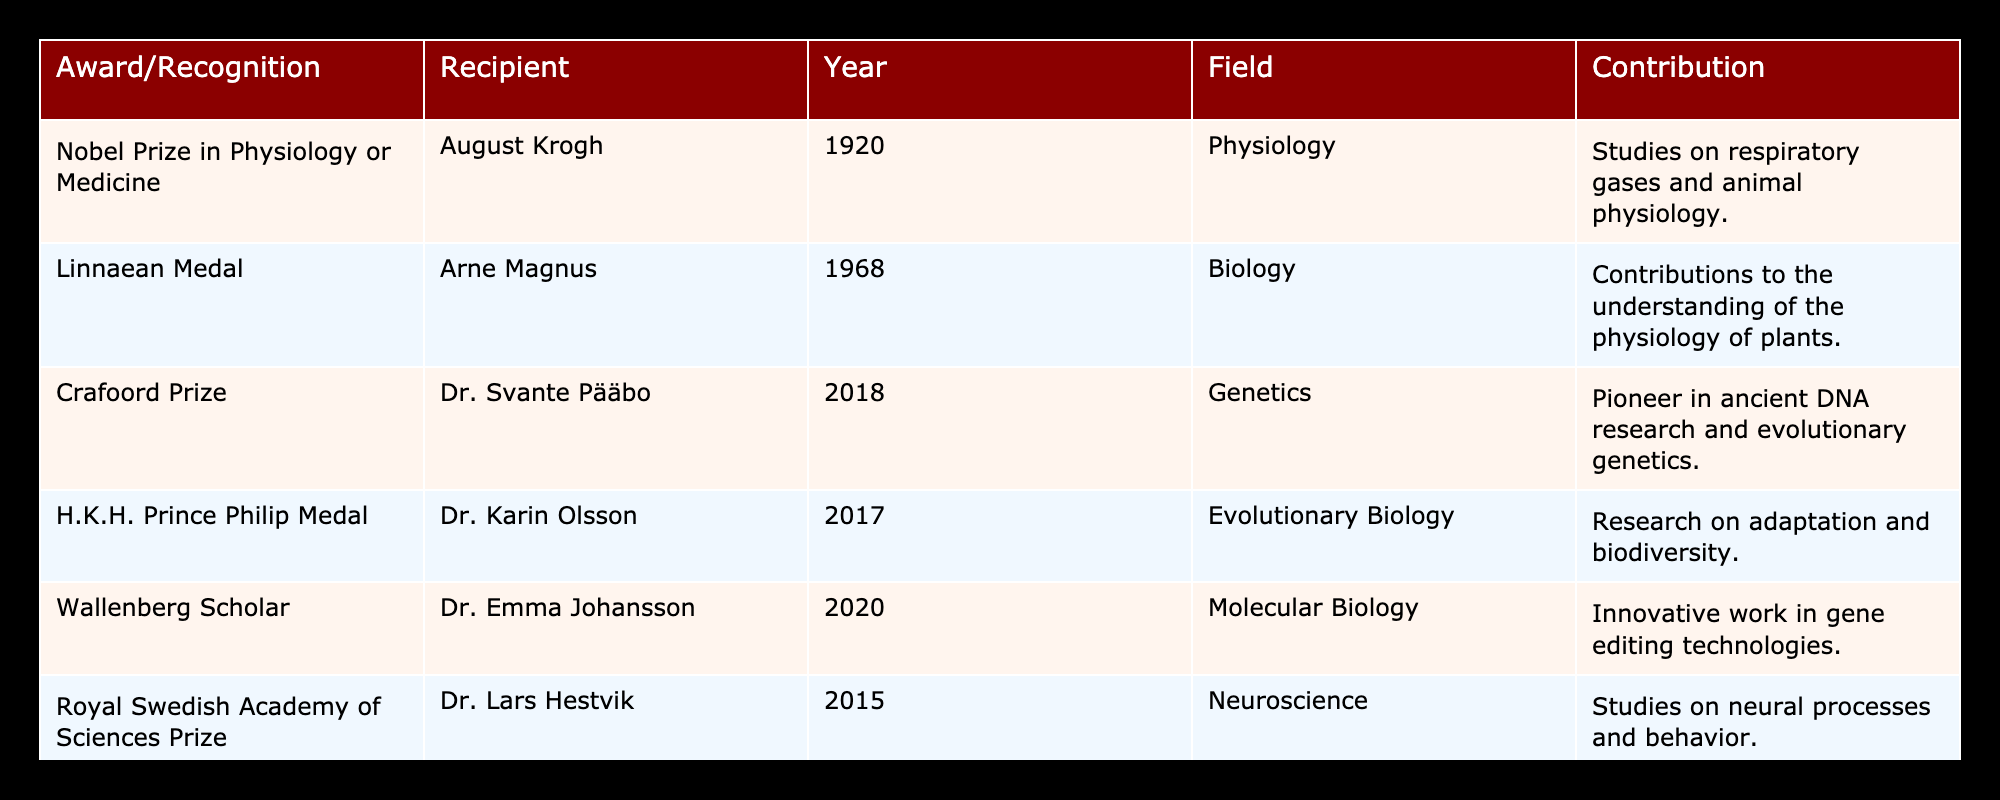What award did August Krogh receive? The table shows that August Krogh received the Nobel Prize in Physiology or Medicine in 1920.
Answer: Nobel Prize in Physiology or Medicine Who was awarded the Crafoord Prize and in what year? According to the table, Dr. Svante Pääbo was awarded the Crafoord Prize in 2018.
Answer: Dr. Svante Pääbo, 2018 How many awards did Dr. Karin Olsson receive? The table indicates that Dr. Karin Olsson received one award, which is the H.K.H. Prince Philip Medal in 2017.
Answer: One award Which field did the recipient of the Royal Swedish Academy of Sciences Prize contribute to? The table states that Dr. Lars Hestvik contributed to Neuroscience when he received the Royal Swedish Academy of Sciences Prize in 2015.
Answer: Neuroscience Which award was given for research on adaptation and biodiversity? From the table, it is clear that the H.K.H. Prince Philip Medal was awarded for research on adaptation and biodiversity to Dr. Karin Olsson.
Answer: H.K.H. Prince Philip Medal What is the average year of the awards listed in the table? Calculating the average year involves summing the years (1920 + 1968 + 2018 + 2017 + 2020 + 2015 + 2011 =  1389) and dividing by the number of awards (7). Thus, the average year is 1389/7 = 1984.14, which rounds to 1984.
Answer: 1984 Did any of the recognized scientists receive multiple awards? By evaluating the table, it is clear that each recipient is listed with only one award, confirming that no recipients received multiple awards.
Answer: No Which scientist received an award in the field of Genetics? The table shows that Dr. Svante Pääbo was recognized for his contributions in the field of Genetics, specifically with the Crafoord Prize in 2018.
Answer: Dr. Svante Pääbo What was the primary contribution of Gustav V's Prize recipient? According to the table, Dr. Bertil Andersson's primary contribution was in research on plant genetics and genomics when he received Gustav V's Prize for Swedish Science in 2011.
Answer: Plant genetics and genomics 